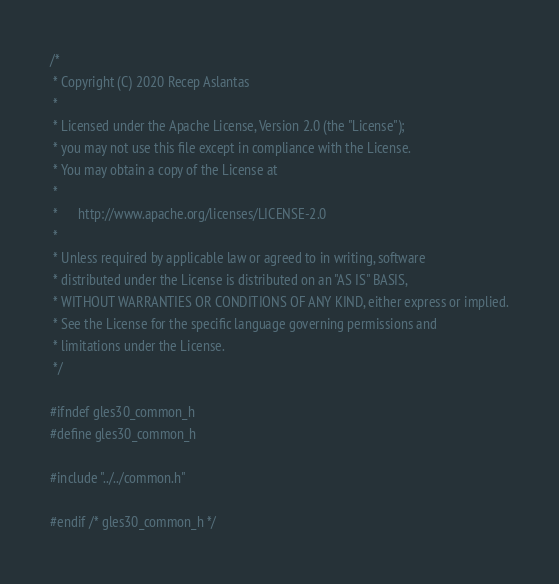Convert code to text. <code><loc_0><loc_0><loc_500><loc_500><_C_>/*
 * Copyright (C) 2020 Recep Aslantas
 *
 * Licensed under the Apache License, Version 2.0 (the "License");
 * you may not use this file except in compliance with the License.
 * You may obtain a copy of the License at
 *
 *      http://www.apache.org/licenses/LICENSE-2.0
 *
 * Unless required by applicable law or agreed to in writing, software
 * distributed under the License is distributed on an "AS IS" BASIS,
 * WITHOUT WARRANTIES OR CONDITIONS OF ANY KIND, either express or implied.
 * See the License for the specific language governing permissions and
 * limitations under the License.
 */

#ifndef gles30_common_h
#define gles30_common_h

#include "../../common.h"

#endif /* gles30_common_h */
</code> 